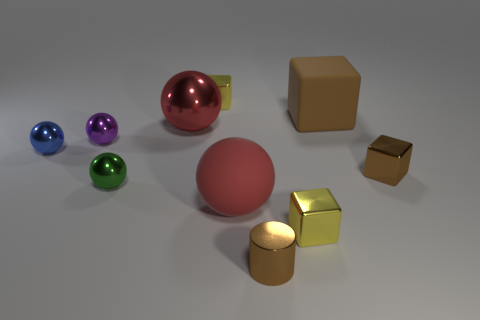Subtract 1 blocks. How many blocks are left? 3 Subtract all cylinders. How many objects are left? 9 Subtract 2 red balls. How many objects are left? 8 Subtract all gray cubes. Subtract all small purple metallic things. How many objects are left? 9 Add 4 tiny metallic cubes. How many tiny metallic cubes are left? 7 Add 3 blue matte spheres. How many blue matte spheres exist? 3 